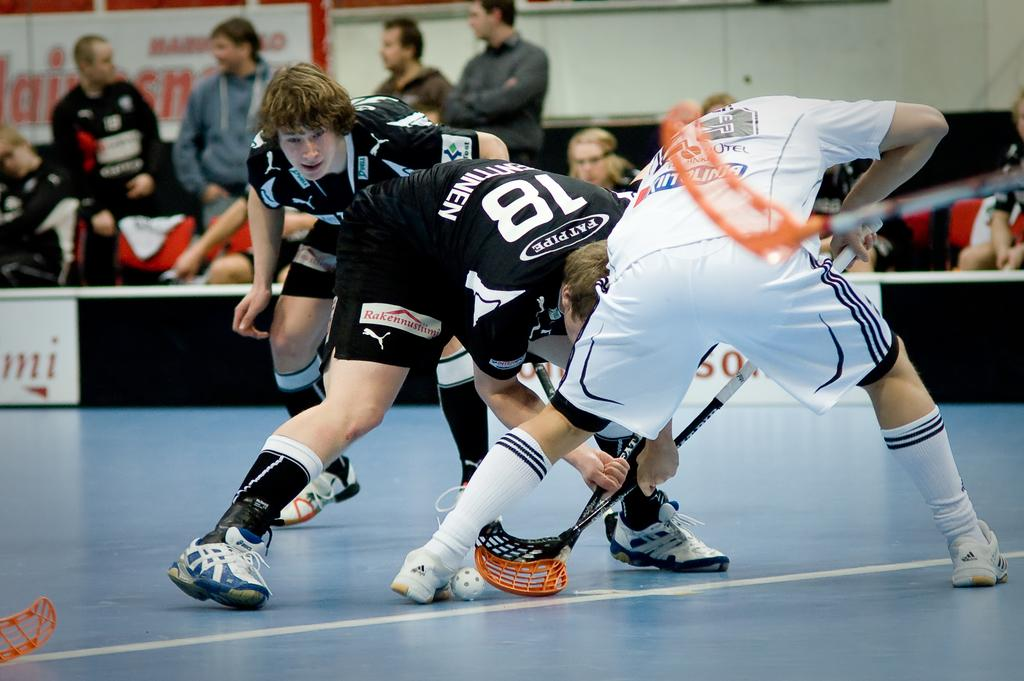<image>
Present a compact description of the photo's key features. Men's Lacrosse game being played in an arena, one of the players has # 18 and says Fatpipe. 